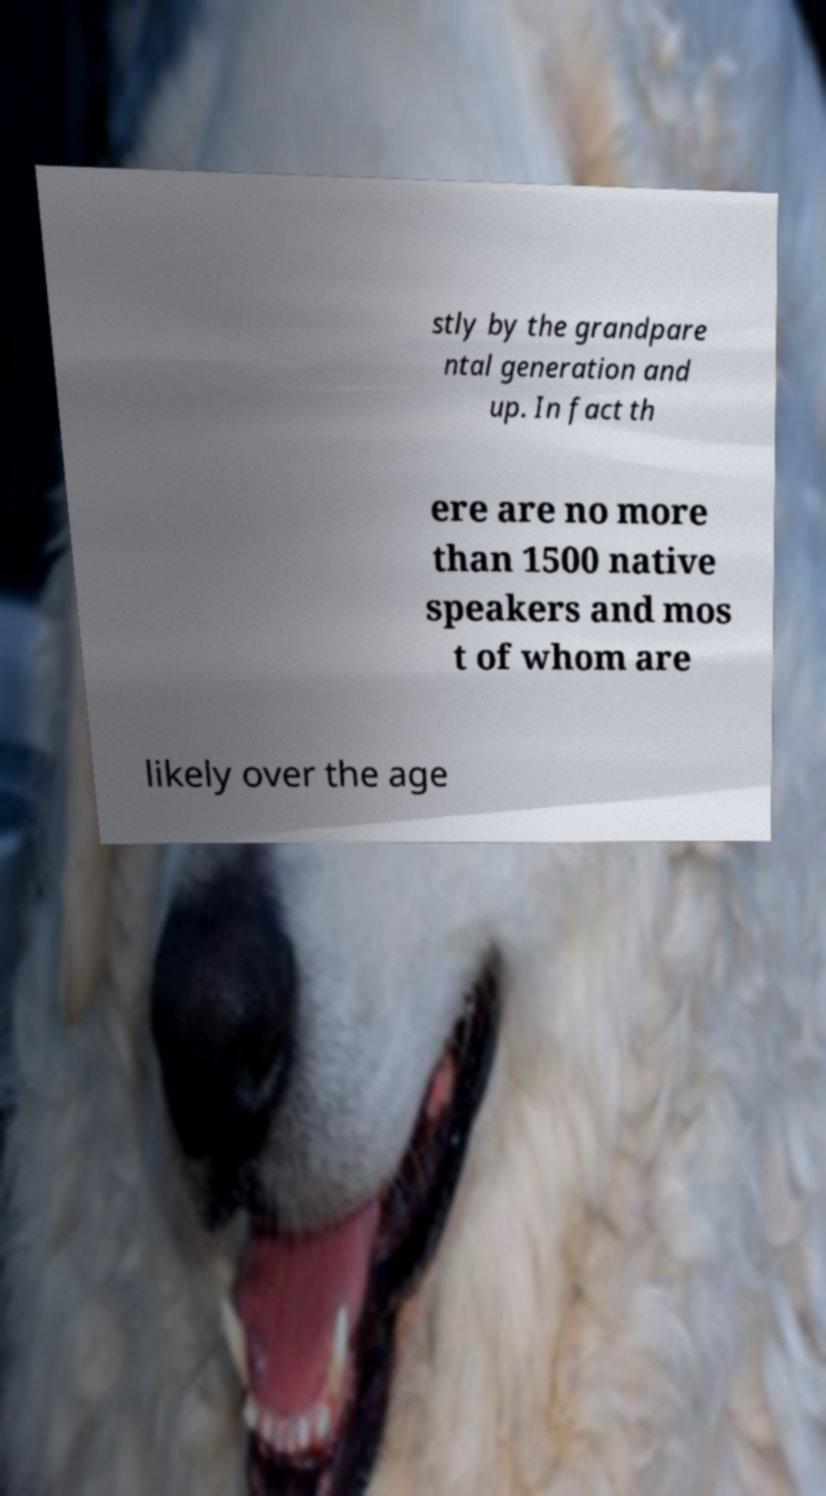Can you read and provide the text displayed in the image?This photo seems to have some interesting text. Can you extract and type it out for me? stly by the grandpare ntal generation and up. In fact th ere are no more than 1500 native speakers and mos t of whom are likely over the age 